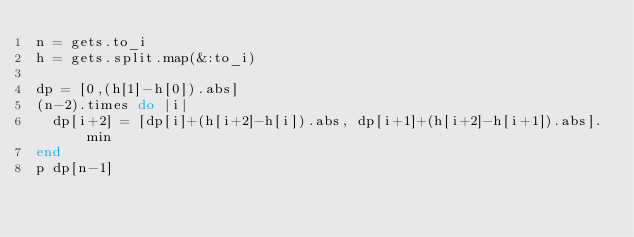<code> <loc_0><loc_0><loc_500><loc_500><_Ruby_>n = gets.to_i
h = gets.split.map(&:to_i)

dp = [0,(h[1]-h[0]).abs]
(n-2).times do |i|
  dp[i+2] = [dp[i]+(h[i+2]-h[i]).abs, dp[i+1]+(h[i+2]-h[i+1]).abs].min
end
p dp[n-1]</code> 